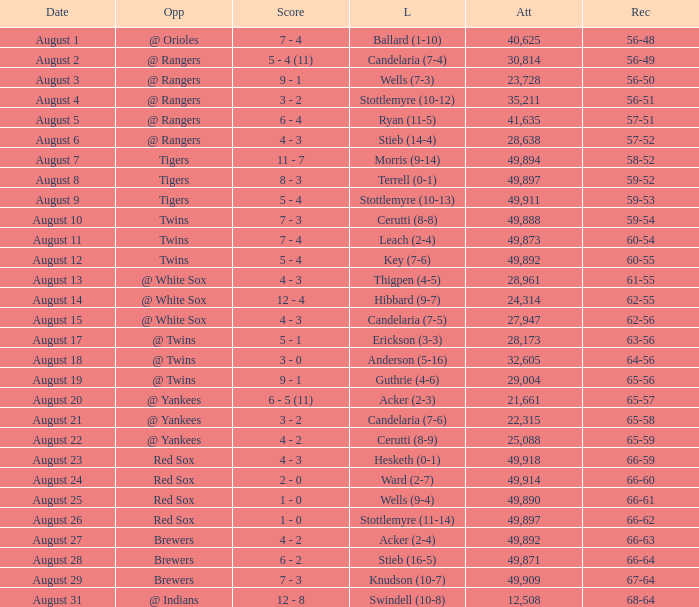What was the record of the game that had a loss of Stottlemyre (10-12)? 56-51. 